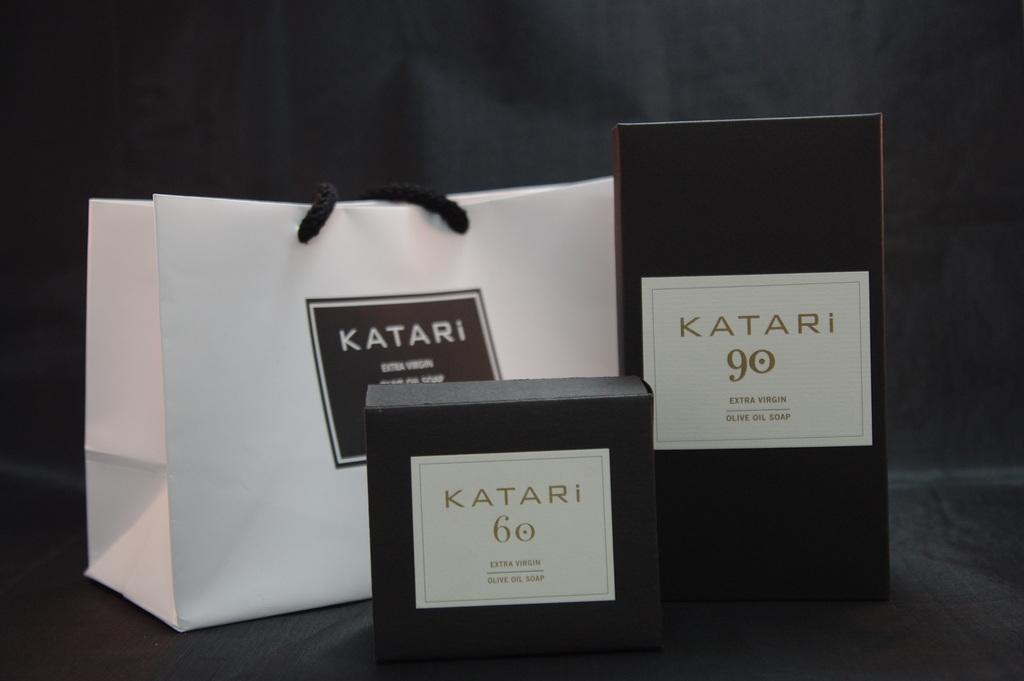Describe this image in one or two sentences. In this picture, we can see few boxes, and bag with text, and numbers on it, we can see background. 